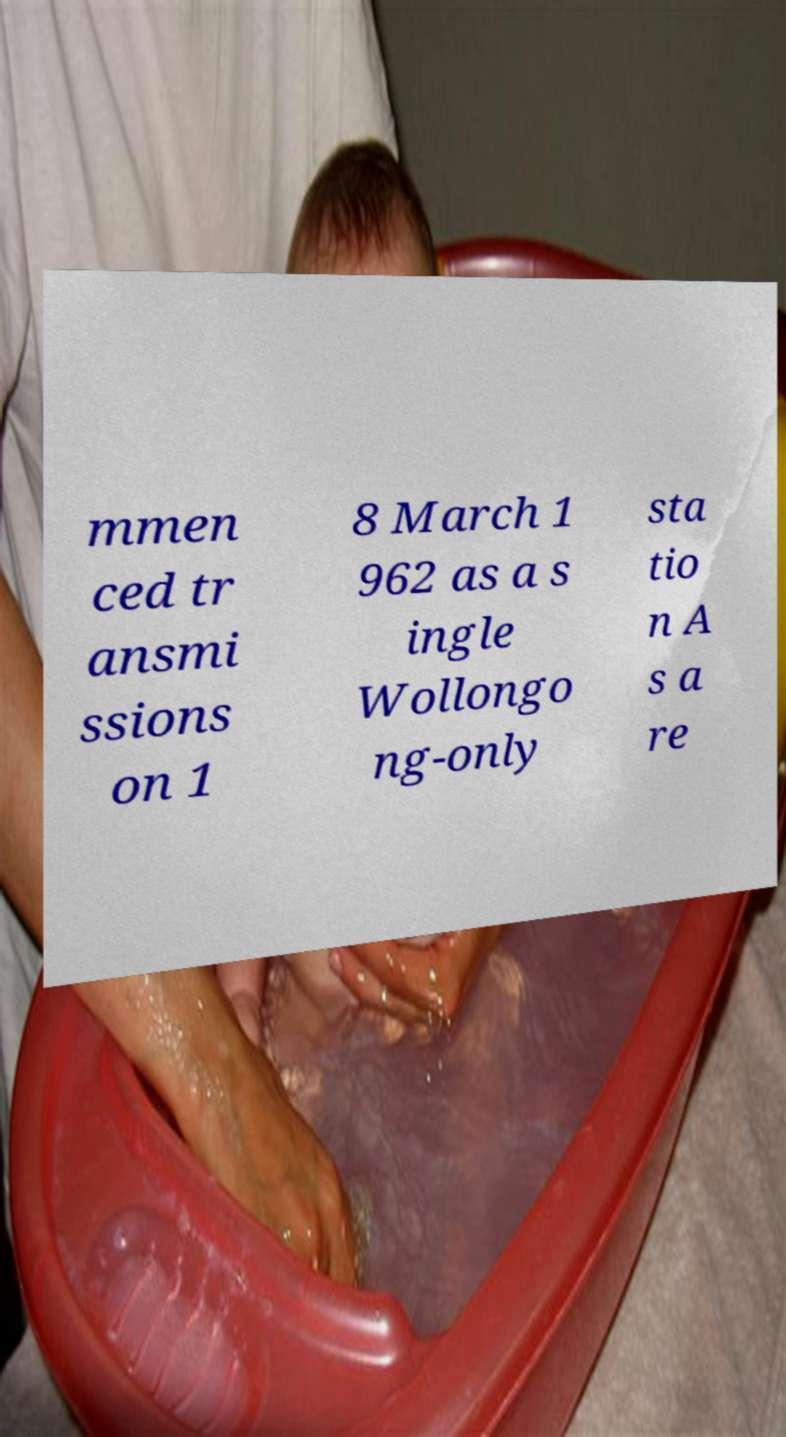I need the written content from this picture converted into text. Can you do that? mmen ced tr ansmi ssions on 1 8 March 1 962 as a s ingle Wollongo ng-only sta tio n A s a re 